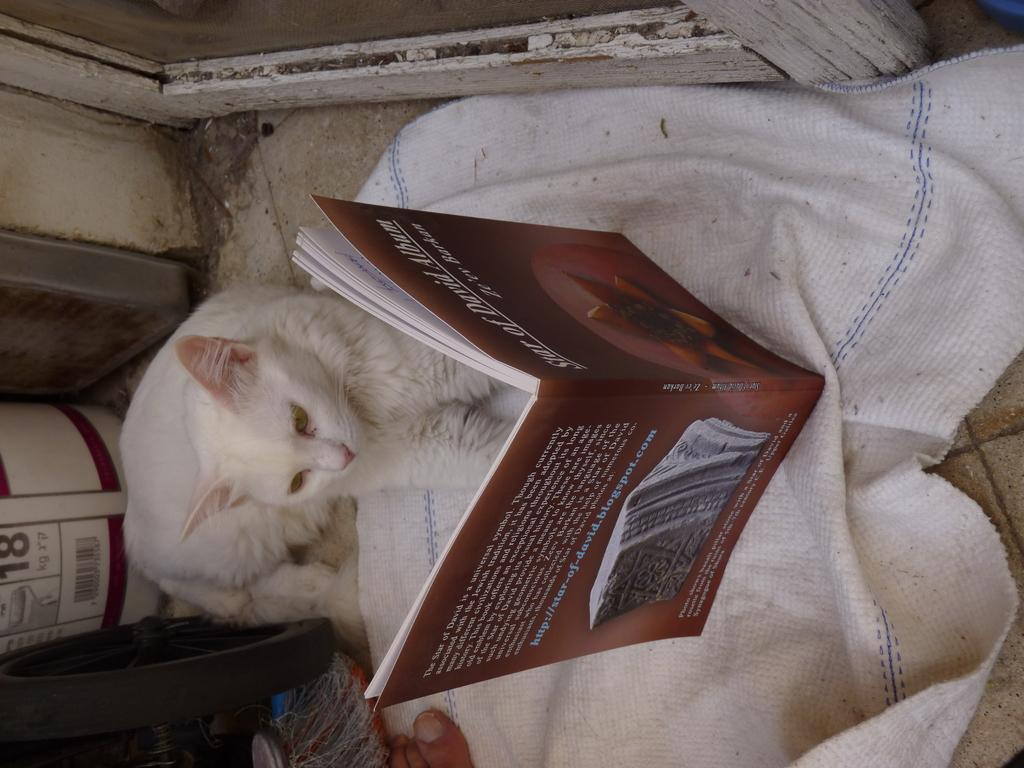What type of animal can be seen in the image? There is a white cat in the image. What object related to reading is present in the image? There is a book in the image. What part of a person's body is visible in the image? A person's toe is visible in the image. What type of material is present in the image? There is a white cloth in the image. What type of fuel is being used by the cat in the image? There is no fuel present in the image, as it features a white cat and other objects. How does the person's muscle contribute to the scene in the image? There is no mention of a person's muscle in the image, as it only shows a white cat, a book, a toe, and a white cloth. 